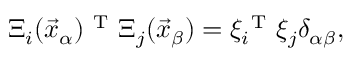<formula> <loc_0><loc_0><loc_500><loc_500>\Xi _ { i } ( \vec { x } _ { \alpha } ) ^ { T } \Xi _ { j } ( \vec { x } _ { \beta } ) = \xi _ { i } ^ { T } \xi _ { j } \delta _ { \alpha \beta } ,</formula> 